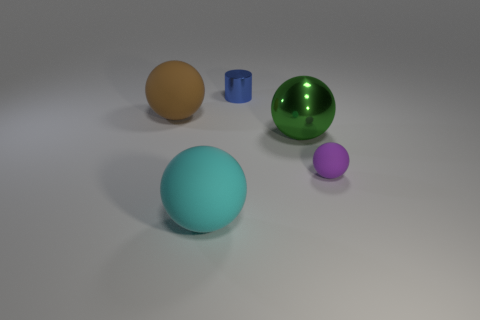Subtract all green spheres. How many spheres are left? 3 Subtract all large cyan matte spheres. How many spheres are left? 3 Add 5 metal things. How many objects exist? 10 Subtract all gray spheres. Subtract all blue cylinders. How many spheres are left? 4 Subtract all cylinders. How many objects are left? 4 Subtract all purple shiny balls. Subtract all rubber objects. How many objects are left? 2 Add 2 blue metallic things. How many blue metallic things are left? 3 Add 2 tiny cyan matte spheres. How many tiny cyan matte spheres exist? 2 Subtract 1 brown spheres. How many objects are left? 4 